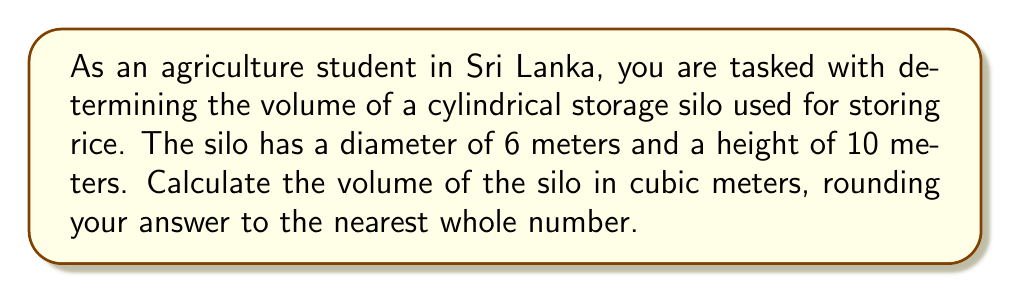Could you help me with this problem? To solve this problem, we need to use the formula for the volume of a cylinder:

$$V = \pi r^2 h$$

Where:
$V$ = volume of the cylinder
$\pi$ = pi (approximately 3.14159)
$r$ = radius of the base
$h$ = height of the cylinder

Let's break down the solution step-by-step:

1. Identify the given dimensions:
   - Diameter = 6 meters
   - Height = 10 meters

2. Calculate the radius:
   The radius is half the diameter.
   $$r = \frac{6}{2} = 3 \text{ meters}$$

3. Apply the volume formula:
   $$V = \pi r^2 h$$
   $$V = \pi \cdot (3 \text{ m})^2 \cdot 10 \text{ m}$$
   $$V = \pi \cdot 9 \text{ m}^2 \cdot 10 \text{ m}$$

4. Calculate the result:
   $$V = 90\pi \text{ m}^3$$
   $$V \approx 90 \cdot 3.14159 \text{ m}^3$$
   $$V \approx 282.74 \text{ m}^3$$

5. Round to the nearest whole number:
   $$V \approx 283 \text{ m}^3$$

Therefore, the volume of the cylindrical storage silo is approximately 283 cubic meters.
Answer: 283 cubic meters 